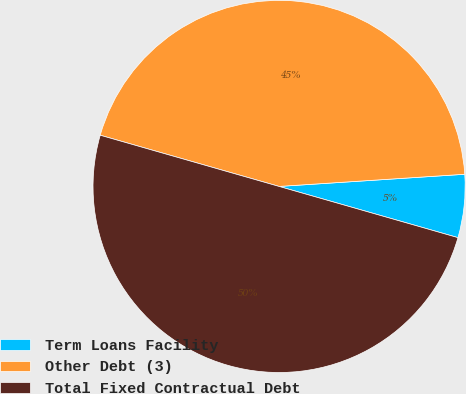Convert chart. <chart><loc_0><loc_0><loc_500><loc_500><pie_chart><fcel>Term Loans Facility<fcel>Other Debt (3)<fcel>Total Fixed Contractual Debt<nl><fcel>5.48%<fcel>44.52%<fcel>50.0%<nl></chart> 